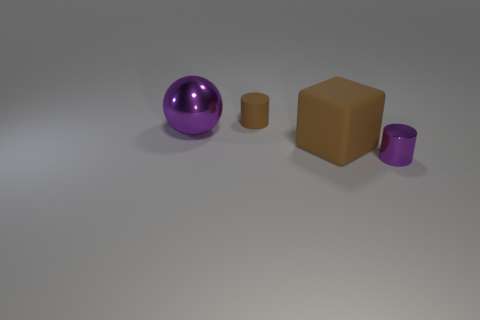Add 3 matte cylinders. How many objects exist? 7 Subtract all blocks. How many objects are left? 3 Subtract all red cylinders. Subtract all cyan cubes. How many cylinders are left? 2 Add 4 small blue rubber blocks. How many small blue rubber blocks exist? 4 Subtract 0 brown balls. How many objects are left? 4 Subtract all purple matte cylinders. Subtract all big spheres. How many objects are left? 3 Add 4 small brown rubber cylinders. How many small brown rubber cylinders are left? 5 